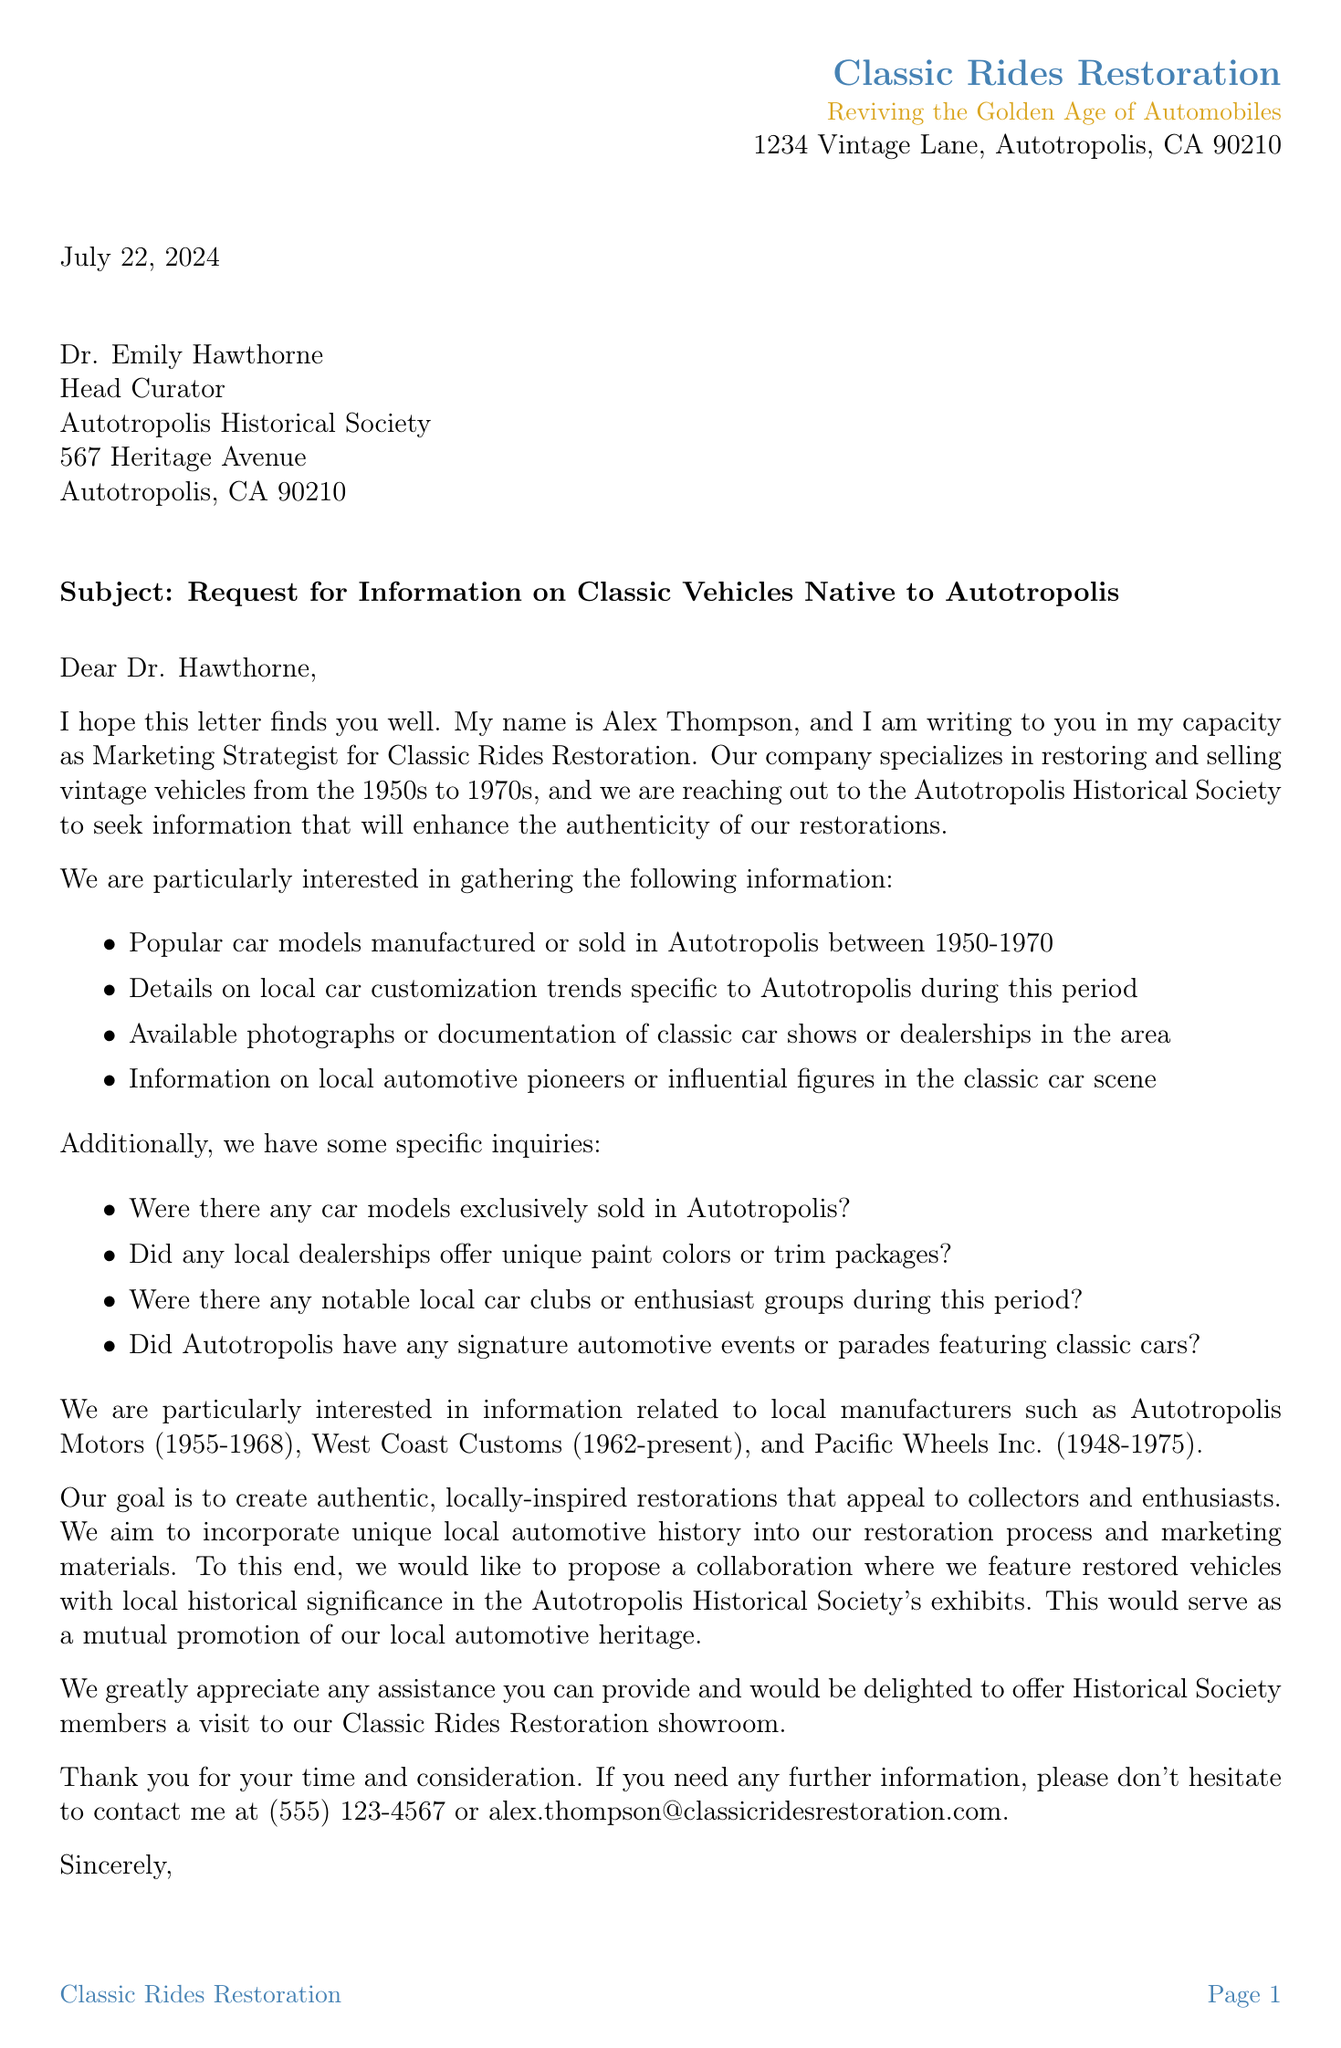What is the sender's name? The sender of the letter is identified at the beginning, and their name is Alex Thompson.
Answer: Alex Thompson What is the recipient's title? The title of the recipient, Dr. Emily Hawthorne, indicates her position at the organization, which is Head Curator.
Answer: Head Curator What period do the classic vehicles of interest cover? The letter specifies that the vehicles in question are from the 1950s to 1970s, outlining the specific decades of interest.
Answer: 1950s to 1970s What is one of the specific inquiries mentioned? The document lists specific inquiries about local car models, including whether any were exclusively sold in Autotropolis.
Answer: Were there any car models exclusively sold in Autotropolis? What is the company’s goal mentioned in the letter? The goal stated in the letter is to create authentic restorations that resonate with local history, appealing to a specific audience.
Answer: To create authentic, locally-inspired restorations What proposal is made for collaboration? The sender proposes to feature restored vehicles with historical significance in the organization's exhibitions, indicating a specific partnership idea.
Answer: Feature restored vehicles with local historical significance in the exhibits What is the contact phone number provided? The letter includes a specific phone number for the sender, which can be used for further communication or inquiries.
Answer: (555) 123-4567 How is the letter signed off? The closing of the letter includes the signature of the sender, indicating formality and appreciation for the recipient's consideration.
Answer: Sincerely 